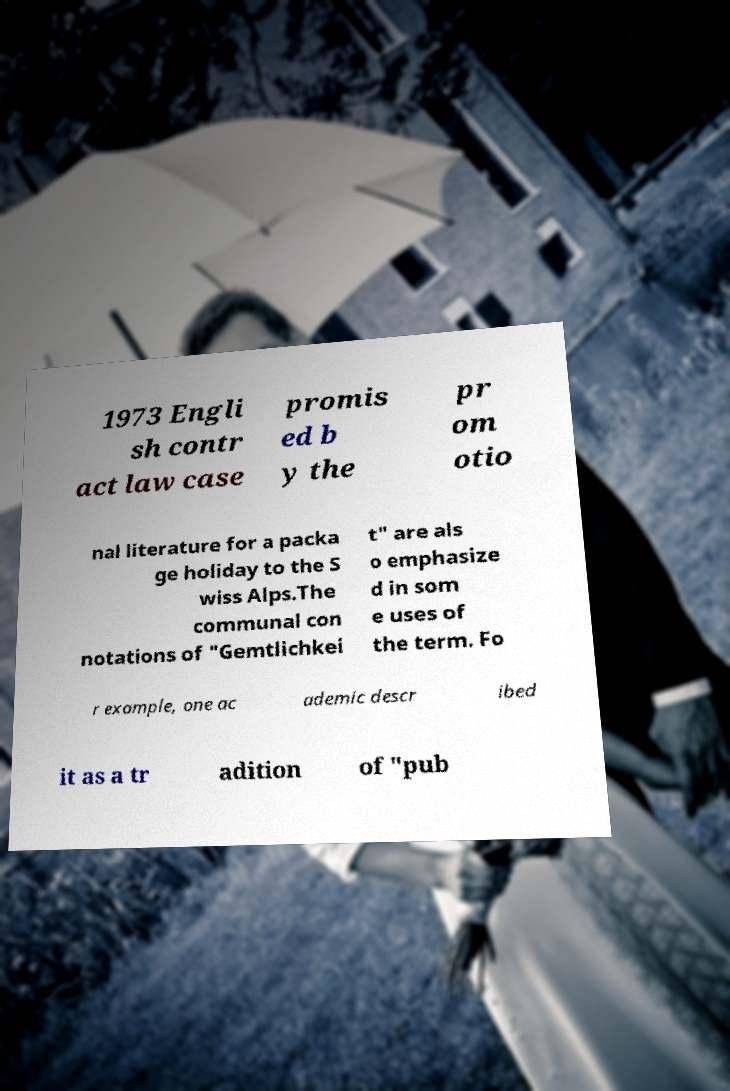Can you accurately transcribe the text from the provided image for me? 1973 Engli sh contr act law case promis ed b y the pr om otio nal literature for a packa ge holiday to the S wiss Alps.The communal con notations of "Gemtlichkei t" are als o emphasize d in som e uses of the term. Fo r example, one ac ademic descr ibed it as a tr adition of "pub 